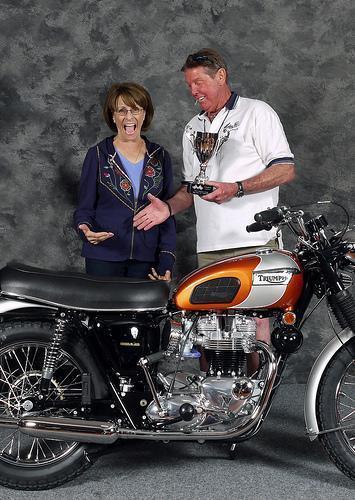How many people are in the picture?
Give a very brief answer. 2. 